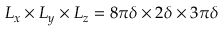<formula> <loc_0><loc_0><loc_500><loc_500>L _ { x } \times L _ { y } \times L _ { z } = 8 \pi \delta \times 2 \delta \times 3 \pi \delta</formula> 